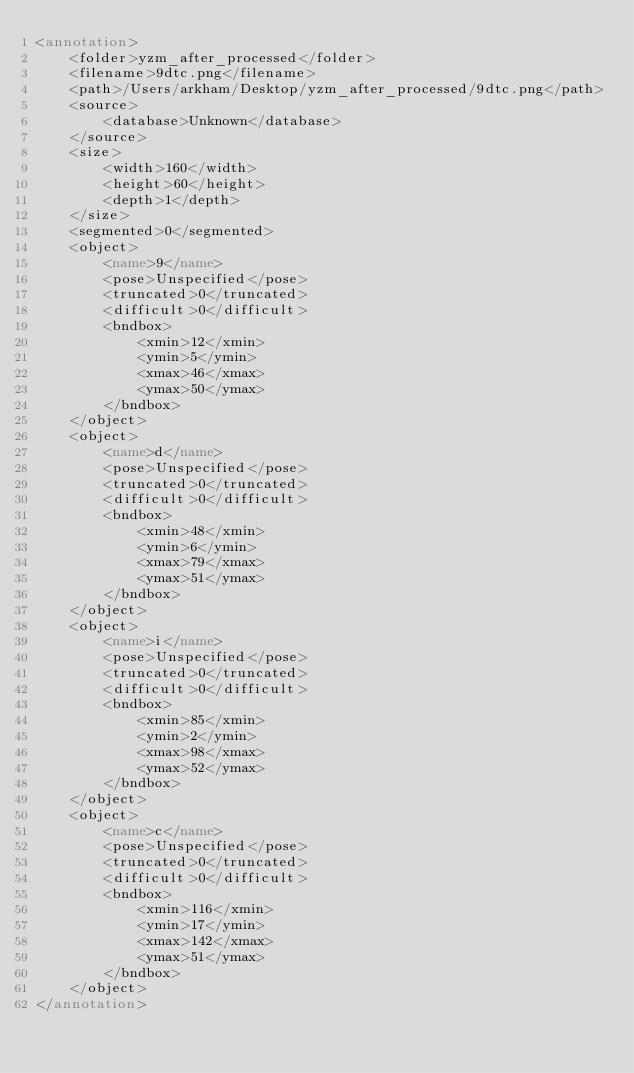Convert code to text. <code><loc_0><loc_0><loc_500><loc_500><_XML_><annotation>
	<folder>yzm_after_processed</folder>
	<filename>9dtc.png</filename>
	<path>/Users/arkham/Desktop/yzm_after_processed/9dtc.png</path>
	<source>
		<database>Unknown</database>
	</source>
	<size>
		<width>160</width>
		<height>60</height>
		<depth>1</depth>
	</size>
	<segmented>0</segmented>
	<object>
		<name>9</name>
		<pose>Unspecified</pose>
		<truncated>0</truncated>
		<difficult>0</difficult>
		<bndbox>
			<xmin>12</xmin>
			<ymin>5</ymin>
			<xmax>46</xmax>
			<ymax>50</ymax>
		</bndbox>
	</object>
	<object>
		<name>d</name>
		<pose>Unspecified</pose>
		<truncated>0</truncated>
		<difficult>0</difficult>
		<bndbox>
			<xmin>48</xmin>
			<ymin>6</ymin>
			<xmax>79</xmax>
			<ymax>51</ymax>
		</bndbox>
	</object>
	<object>
		<name>i</name>
		<pose>Unspecified</pose>
		<truncated>0</truncated>
		<difficult>0</difficult>
		<bndbox>
			<xmin>85</xmin>
			<ymin>2</ymin>
			<xmax>98</xmax>
			<ymax>52</ymax>
		</bndbox>
	</object>
	<object>
		<name>c</name>
		<pose>Unspecified</pose>
		<truncated>0</truncated>
		<difficult>0</difficult>
		<bndbox>
			<xmin>116</xmin>
			<ymin>17</ymin>
			<xmax>142</xmax>
			<ymax>51</ymax>
		</bndbox>
	</object>
</annotation>
</code> 